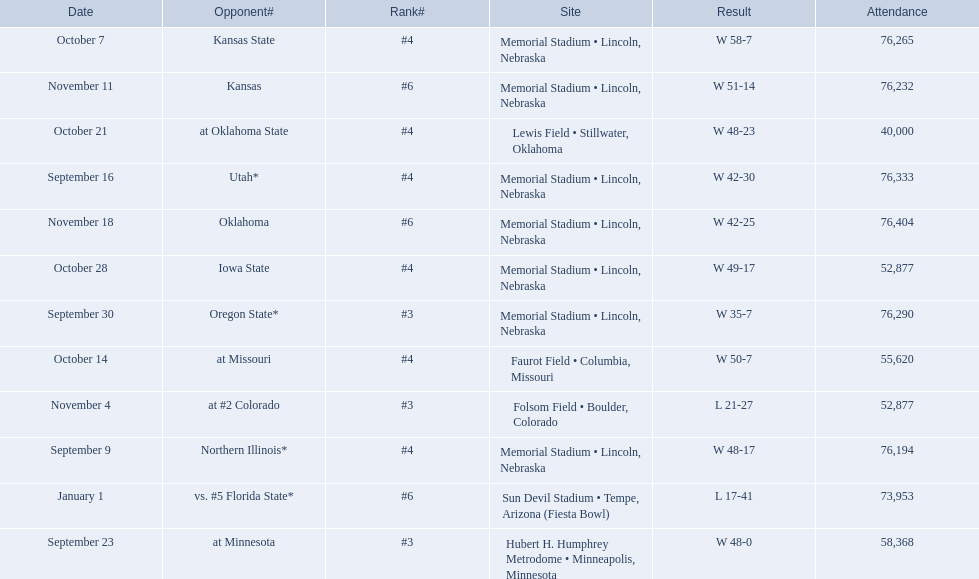Who were all of their opponents? Northern Illinois*, Utah*, at Minnesota, Oregon State*, Kansas State, at Missouri, at Oklahoma State, Iowa State, at #2 Colorado, Kansas, Oklahoma, vs. #5 Florida State*. And what was the attendance of these games? 76,194, 76,333, 58,368, 76,290, 76,265, 55,620, 40,000, 52,877, 52,877, 76,232, 76,404, 73,953. Of those numbers, which is associated with the oregon state game? 76,290. 